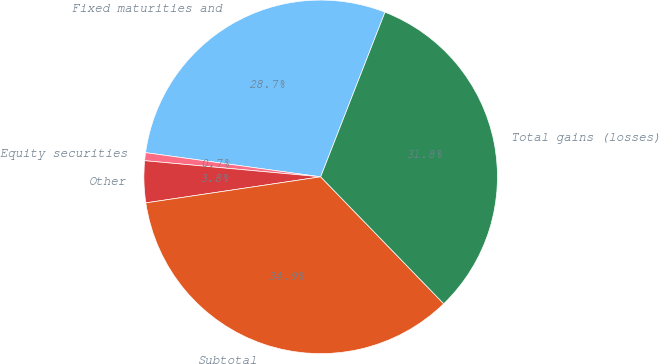Convert chart to OTSL. <chart><loc_0><loc_0><loc_500><loc_500><pie_chart><fcel>Fixed maturities and<fcel>Equity securities<fcel>Other<fcel>Subtotal<fcel>Total gains (losses)<nl><fcel>28.74%<fcel>0.73%<fcel>3.81%<fcel>34.9%<fcel>31.82%<nl></chart> 